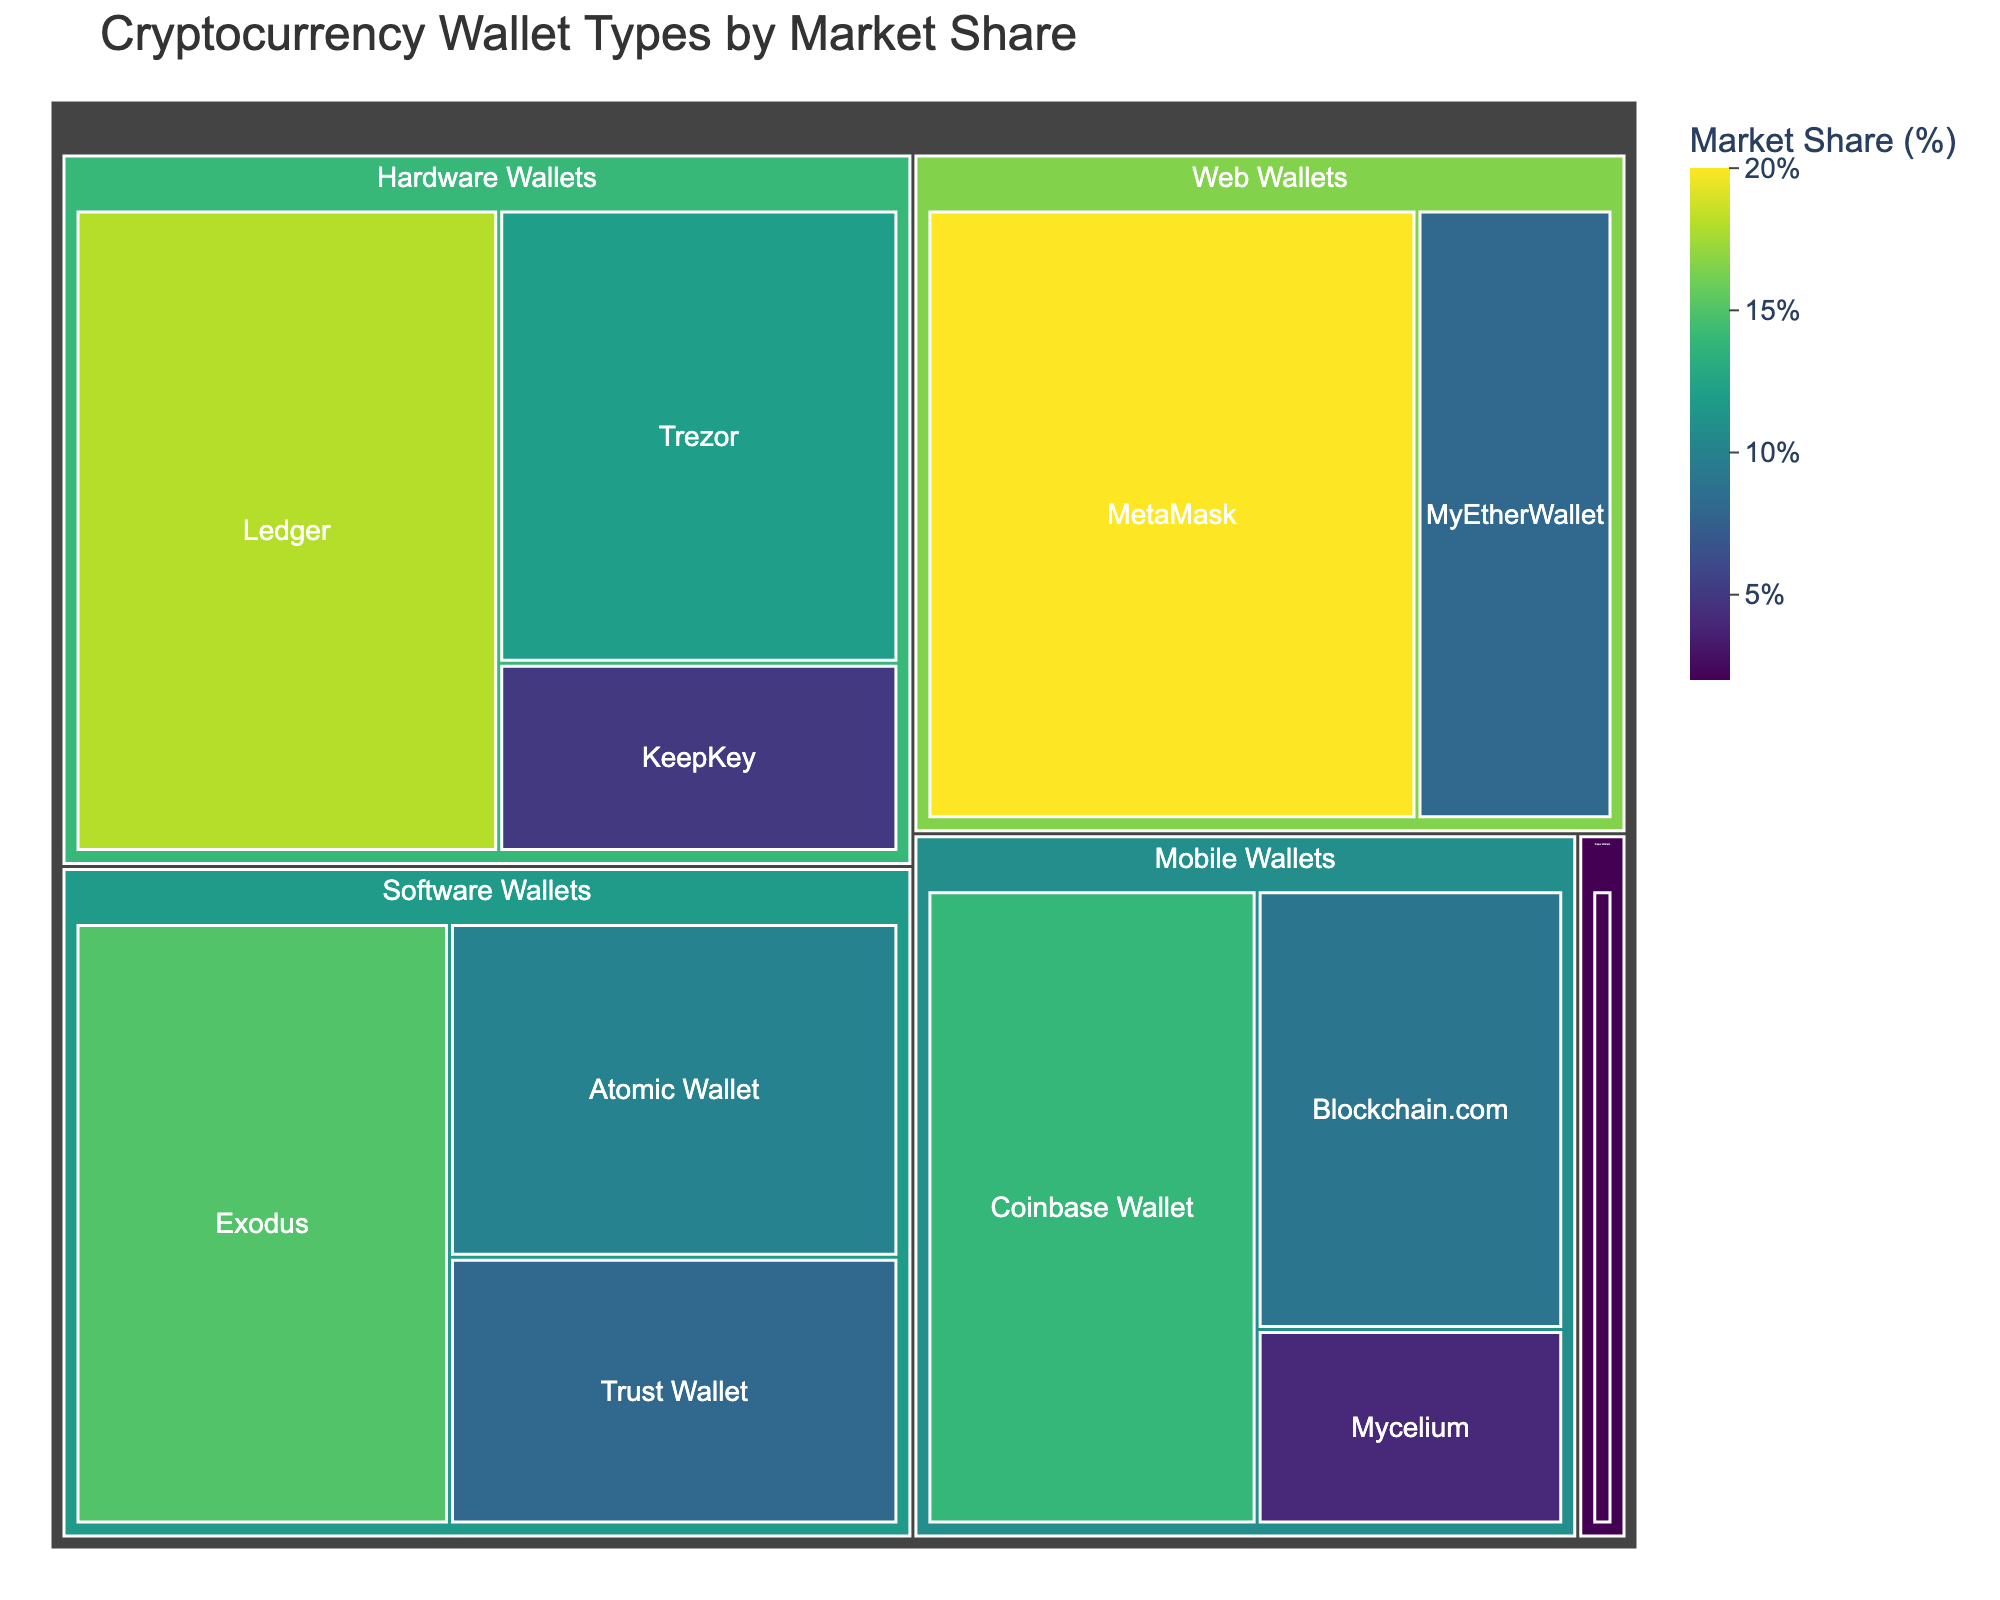What is the title of the treemap? The title of a plot is typically placed at the top, serving as an overall description of the information being visualized. In this case, the title "Cryptocurrency Wallet Types by Market Share" is prominently displayed at the top of the treemap.
Answer: Cryptocurrency Wallet Types by Market Share Which wallet type has the largest market share? By examining the size of the blocks in the treemap, we can identify which wallet types have the largest market share. The block under "Web Wallets" with "MetaMask" has the largest area, indicating it has the largest market share.
Answer: MetaMask How much is the combined market share of Ledger and Trezor? Ledger has a market share of 18%, and Trezor has a market share of 12%. Adding these values together gives us the combined market share: 18 + 12 = 30%.
Answer: 30% Which type of wallet falls under the category with the smallest overall market share? Paper Wallets is the category with the smallest market share, as indicated by the size of its block. The type within this category is labeled "Various."
Answer: Various Compare the market share of Mobile Wallets and Web Wallets. We look at the sum of the market shares in each category. For Mobile Wallets: 14% (Coinbase Wallet) + 9% (Blockchain.com) + 4% (Mycelium) = 27%. For Web Wallets: 20% (MetaMask) + 8% (MyEtherWallet) = 28%. Hence, Web Wallets have a slightly higher market share.
Answer: Web Wallets have a higher market share Which Software Wallet has a lower market share, Trust Wallet or Atomic Wallet? In the treemap, we locate Trust Wallet and Atomic Wallet under the Software Wallets category. Trust Wallet has an 8% market share, while Atomic Wallet has a 10% market share. Therefore, Trust Wallet has a lower market share.
Answer: Trust Wallet What is the total market share of all the Hardware Wallets combined? Adding the market shares for all Hardware Wallets: Ledger (18%) + Trezor (12%) + KeepKey (5%) = 35%.
Answer: 35% How does the market share of Mobile Wallets' Coinbase Wallet compare to Software Wallets' Exodus? Coinbase Wallet has a 14% market share, while Exodus has a 15% market share. By comparing these percentages, we can see that Exodus has a slightly higher market share than Coinbase Wallet.
Answer: Exodus has a higher market share What color scheme is used to represent the market share in the treemap? The treemap uses a color scheme called "Viridis" to represent varying levels of market share visually. This color scheme uses a range of colors to indicate different percentage values.
Answer: Viridis How does the market share of the largest category compare to the overall aggregate market share (sum of all categories)? To solve this, we first need to determine the market share sum of each category and identify the largest. The largest category by Market Share is Web Wallets with 28%. Calculating the total aggregate (by summing all percentages): 18 + 12 + 5 + 15 + 10 + 8 + 14 + 9 + 4 + 20 + 8 + 2 = 125%. Therefore, 28% (Web Wallets) out of 125% total market share.
Answer: 28% out of 125% 